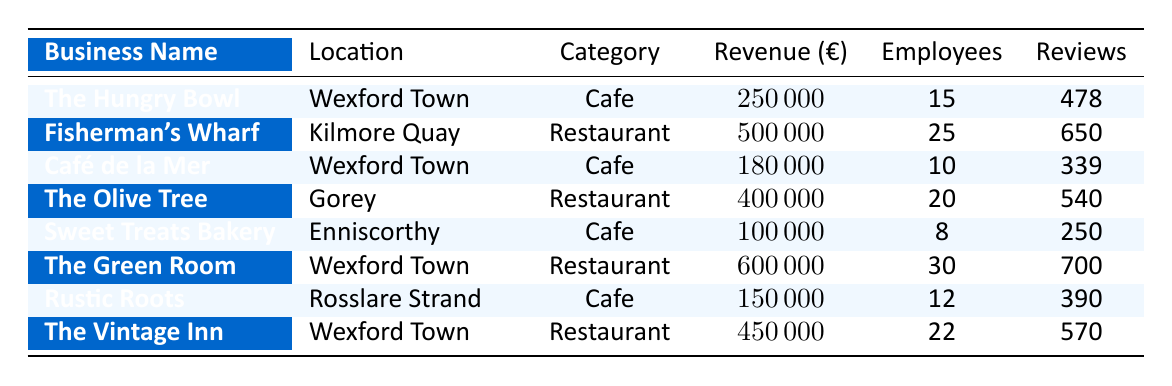What is the revenue of The Hungry Bowl? The table lists The Hungry Bowl's revenue under the revenue column, which shows that it is 250,000 euros.
Answer: 250000 Which restaurant has the highest revenue? Looking through the revenue column, The Green Room has the highest revenue of 600,000 euros compared to all other restaurants listed.
Answer: The Green Room What is the total revenue of all cafes? The total revenue can be calculated by adding the revenues of all cafes: 250,000 (The Hungry Bowl) + 180,000 (Café de la Mer) + 100,000 (Sweet Treats Bakery) + 150,000 (Rustic Roots) = 680,000 euros.
Answer: 680000 How many employees does The Olive Tree have? The table has a direct entry for The Olive Tree, which indicates it has 20 employees.
Answer: 20 Which location has the highest number of customer reviews? Analyzing the customer reviews column, The Green Room has 700 reviews, which is the highest among all entries.
Answer: The Green Room What is the average revenue of the restaurants? To find the average revenue of the restaurants: sum their revenues (500,000 + 400,000 + 600,000 + 450,000) = 1,950,000 euros. There are 4 restaurants, so the average is 1,950,000 / 4 = 487,500 euros.
Answer: 487500 Is Sweet Treats Bakery located in Wexford Town? The table indicates that Sweet Treats Bakery is located in Enniscorthy, not Wexford Town.
Answer: No What’s the total number of employees among all businesses? By summing the number of employees: 15 (The Hungry Bowl) + 25 (Fisherman's Wharf) + 10 (Café de la Mer) + 20 (The Olive Tree) + 8 (Sweet Treats Bakery) + 30 (The Green Room) + 12 (Rustic Roots) + 22 (The Vintage Inn) = 142 employees.
Answer: 142 Which cafe received the least customer reviews? The cafe with the lowest customer reviews is Sweet Treats Bakery, with 250 reviews.
Answer: Sweet Treats Bakery What is the difference in revenue between The Green Room and Café de la Mer? The revenue of The Green Room is 600,000 euros and that of Café de la Mer is 180,000 euros. Therefore, the difference is 600,000 - 180,000 = 420,000 euros.
Answer: 420000 